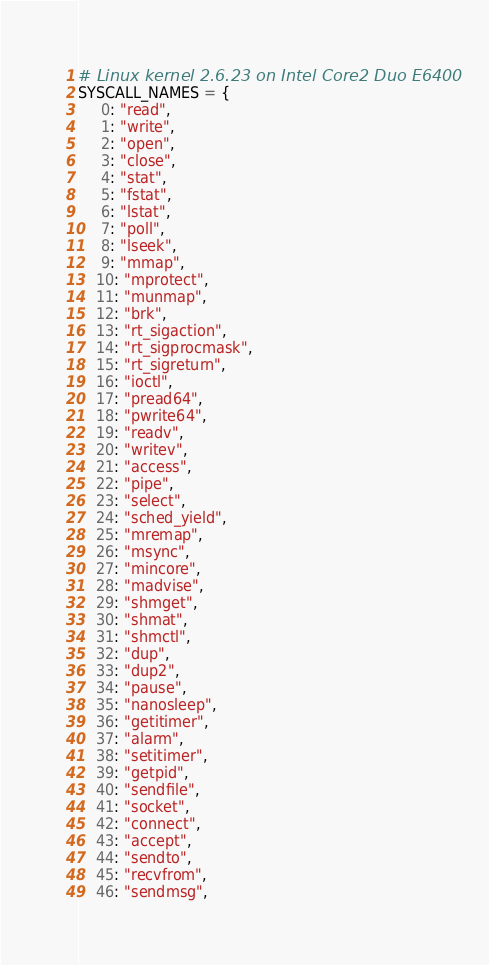<code> <loc_0><loc_0><loc_500><loc_500><_Python_># Linux kernel 2.6.23 on Intel Core2 Duo E6400
SYSCALL_NAMES = {
     0: "read",
     1: "write",
     2: "open",
     3: "close",
     4: "stat",
     5: "fstat",
     6: "lstat",
     7: "poll",
     8: "lseek",
     9: "mmap",
    10: "mprotect",
    11: "munmap",
    12: "brk",
    13: "rt_sigaction",
    14: "rt_sigprocmask",
    15: "rt_sigreturn",
    16: "ioctl",
    17: "pread64",
    18: "pwrite64",
    19: "readv",
    20: "writev",
    21: "access",
    22: "pipe",
    23: "select",
    24: "sched_yield",
    25: "mremap",
    26: "msync",
    27: "mincore",
    28: "madvise",
    29: "shmget",
    30: "shmat",
    31: "shmctl",
    32: "dup",
    33: "dup2",
    34: "pause",
    35: "nanosleep",
    36: "getitimer",
    37: "alarm",
    38: "setitimer",
    39: "getpid",
    40: "sendfile",
    41: "socket",
    42: "connect",
    43: "accept",
    44: "sendto",
    45: "recvfrom",
    46: "sendmsg",</code> 